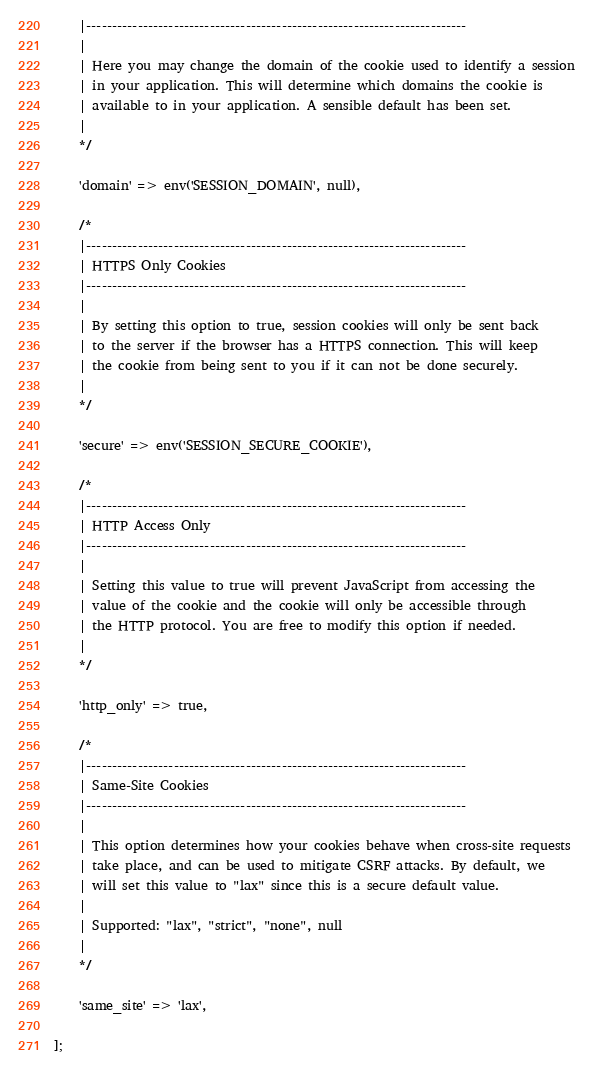Convert code to text. <code><loc_0><loc_0><loc_500><loc_500><_PHP_>    |--------------------------------------------------------------------------
    |
    | Here you may change the domain of the cookie used to identify a session
    | in your application. This will determine which domains the cookie is
    | available to in your application. A sensible default has been set.
    |
    */

    'domain' => env('SESSION_DOMAIN', null),

    /*
    |--------------------------------------------------------------------------
    | HTTPS Only Cookies
    |--------------------------------------------------------------------------
    |
    | By setting this option to true, session cookies will only be sent back
    | to the server if the browser has a HTTPS connection. This will keep
    | the cookie from being sent to you if it can not be done securely.
    |
    */

    'secure' => env('SESSION_SECURE_COOKIE'),

    /*
    |--------------------------------------------------------------------------
    | HTTP Access Only
    |--------------------------------------------------------------------------
    |
    | Setting this value to true will prevent JavaScript from accessing the
    | value of the cookie and the cookie will only be accessible through
    | the HTTP protocol. You are free to modify this option if needed.
    |
    */

    'http_only' => true,

    /*
    |--------------------------------------------------------------------------
    | Same-Site Cookies
    |--------------------------------------------------------------------------
    |
    | This option determines how your cookies behave when cross-site requests
    | take place, and can be used to mitigate CSRF attacks. By default, we
    | will set this value to "lax" since this is a secure default value.
    |
    | Supported: "lax", "strict", "none", null
    |
    */

    'same_site' => 'lax',

];
</code> 